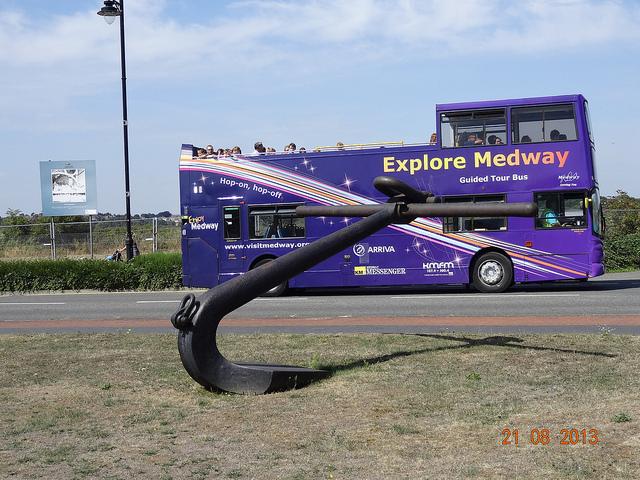What brand of bus is this?
Write a very short answer. Explore medway. What is the main color of the bus?
Give a very brief answer. Purple. Is this a sightseeing double deckers?
Concise answer only. Yes. 